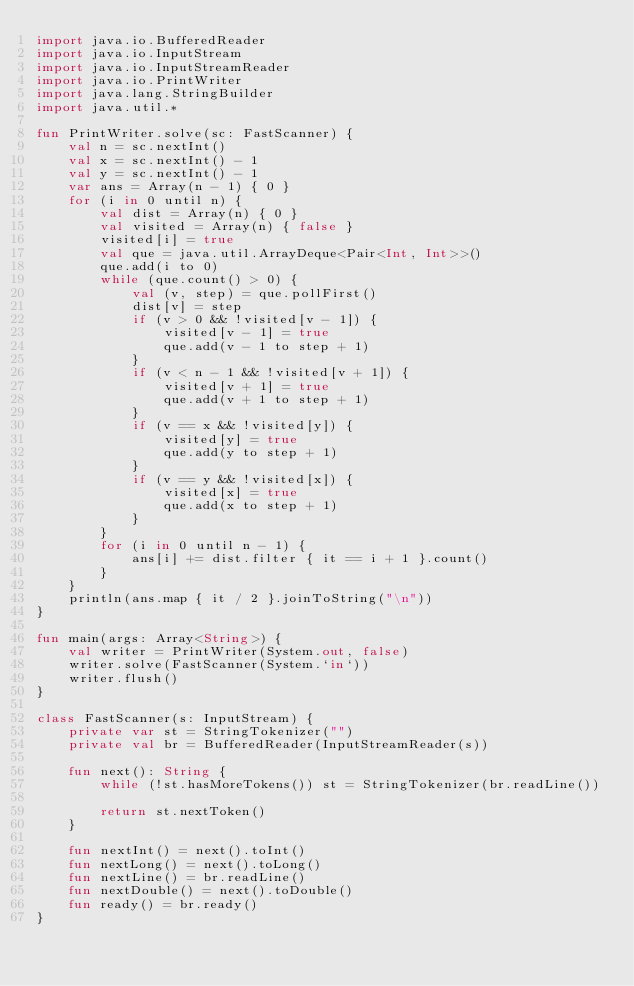Convert code to text. <code><loc_0><loc_0><loc_500><loc_500><_Kotlin_>import java.io.BufferedReader
import java.io.InputStream
import java.io.InputStreamReader
import java.io.PrintWriter
import java.lang.StringBuilder
import java.util.*

fun PrintWriter.solve(sc: FastScanner) {
    val n = sc.nextInt()
    val x = sc.nextInt() - 1
    val y = sc.nextInt() - 1
    var ans = Array(n - 1) { 0 }
    for (i in 0 until n) {
        val dist = Array(n) { 0 }
        val visited = Array(n) { false }
        visited[i] = true
        val que = java.util.ArrayDeque<Pair<Int, Int>>()
        que.add(i to 0)
        while (que.count() > 0) {
            val (v, step) = que.pollFirst()
            dist[v] = step
            if (v > 0 && !visited[v - 1]) {
                visited[v - 1] = true
                que.add(v - 1 to step + 1)
            }
            if (v < n - 1 && !visited[v + 1]) {
                visited[v + 1] = true
                que.add(v + 1 to step + 1)
            }
            if (v == x && !visited[y]) {
                visited[y] = true
                que.add(y to step + 1)
            }
            if (v == y && !visited[x]) {
                visited[x] = true
                que.add(x to step + 1)
            }
        }
        for (i in 0 until n - 1) {
            ans[i] += dist.filter { it == i + 1 }.count()
        }
    }
    println(ans.map { it / 2 }.joinToString("\n"))
}

fun main(args: Array<String>) {
    val writer = PrintWriter(System.out, false)
    writer.solve(FastScanner(System.`in`))
    writer.flush()
}

class FastScanner(s: InputStream) {
    private var st = StringTokenizer("")
    private val br = BufferedReader(InputStreamReader(s))

    fun next(): String {
        while (!st.hasMoreTokens()) st = StringTokenizer(br.readLine())

        return st.nextToken()
    }

    fun nextInt() = next().toInt()
    fun nextLong() = next().toLong()
    fun nextLine() = br.readLine()
    fun nextDouble() = next().toDouble()
    fun ready() = br.ready()
}
</code> 